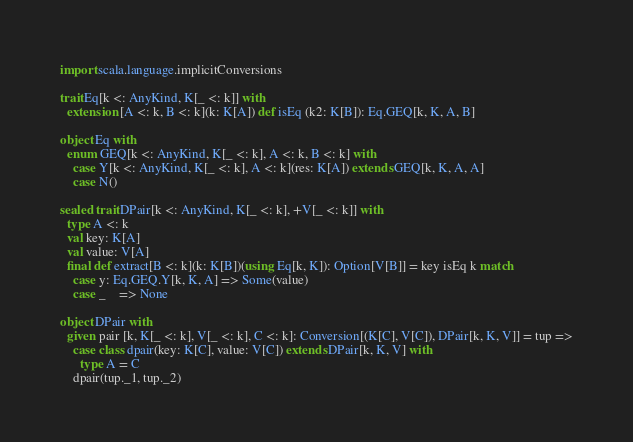Convert code to text. <code><loc_0><loc_0><loc_500><loc_500><_Scala_>import scala.language.implicitConversions

trait Eq[k <: AnyKind, K[_ <: k]] with
  extension [A <: k, B <: k](k: K[A]) def isEq (k2: K[B]): Eq.GEQ[k, K, A, B]

object Eq with
  enum GEQ[k <: AnyKind, K[_ <: k], A <: k, B <: k] with
    case Y[k <: AnyKind, K[_ <: k], A <: k](res: K[A]) extends GEQ[k, K, A, A]
    case N()

sealed trait DPair[k <: AnyKind, K[_ <: k], +V[_ <: k]] with
  type A <: k
  val key: K[A]
  val value: V[A]
  final def extract[B <: k](k: K[B])(using Eq[k, K]): Option[V[B]] = key isEq k match
    case y: Eq.GEQ.Y[k, K, A] => Some(value)
    case _    => None

object DPair with
  given pair [k, K[_ <: k], V[_ <: k], C <: k]: Conversion[(K[C], V[C]), DPair[k, K, V]] = tup =>
    case class dpair(key: K[C], value: V[C]) extends DPair[k, K, V] with
      type A = C
    dpair(tup._1, tup._2)
</code> 